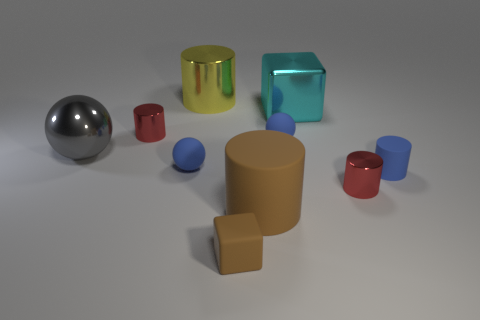Subtract all blue matte cylinders. How many cylinders are left? 4 Subtract all small rubber spheres. Subtract all small blue rubber cylinders. How many objects are left? 7 Add 7 large yellow shiny cylinders. How many large yellow shiny cylinders are left? 8 Add 4 matte cubes. How many matte cubes exist? 5 Subtract all gray balls. How many balls are left? 2 Subtract 0 cyan cylinders. How many objects are left? 10 Subtract all balls. How many objects are left? 7 Subtract 1 balls. How many balls are left? 2 Subtract all purple spheres. Subtract all red cylinders. How many spheres are left? 3 Subtract all cyan blocks. How many blue balls are left? 2 